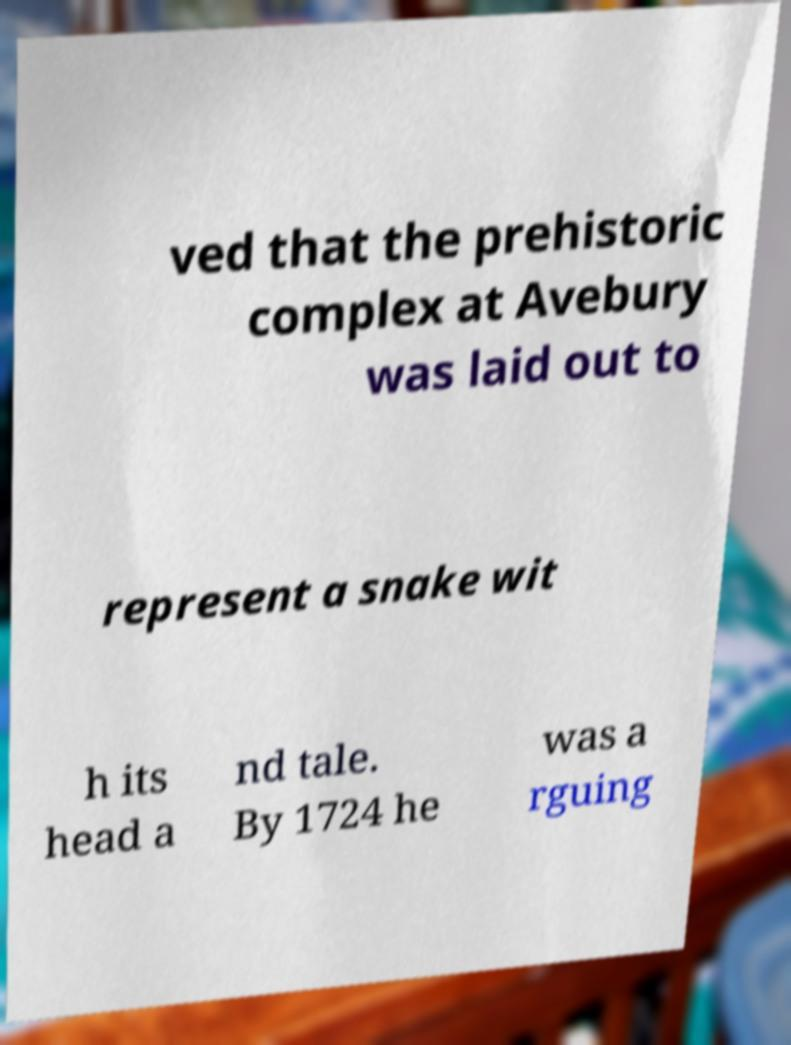Could you extract and type out the text from this image? ved that the prehistoric complex at Avebury was laid out to represent a snake wit h its head a nd tale. By 1724 he was a rguing 